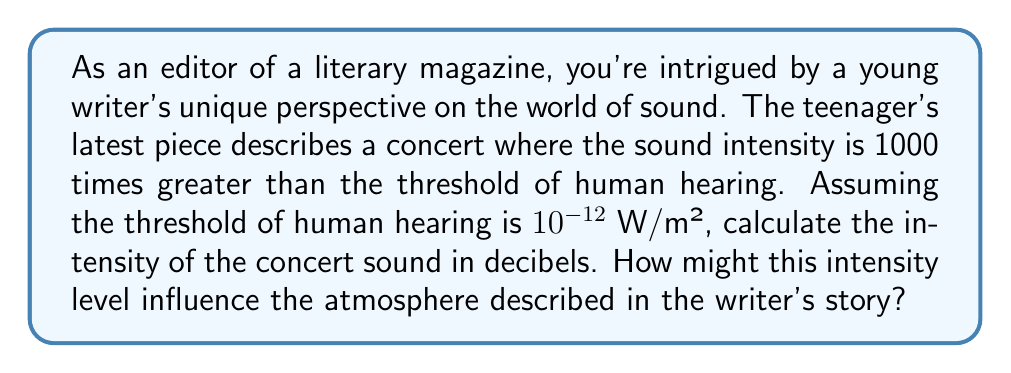Help me with this question. To solve this problem, we'll use the formula for sound intensity level in decibels:

$$ L = 10 \log_{10} \left(\frac{I}{I_0}\right) $$

Where:
$L$ is the sound intensity level in decibels (dB)
$I$ is the intensity of the sound in W/m²
$I_0$ is the reference intensity, which is the threshold of human hearing ($10^{-12}$ W/m²)

Given:
- The concert sound intensity is 1000 times greater than the threshold of human hearing
- $I_0 = 10^{-12}$ W/m²

Step 1: Calculate the intensity of the concert sound ($I$)
$I = 1000 \times I_0 = 1000 \times 10^{-12} = 10^{-9}$ W/m²

Step 2: Plug the values into the formula
$$ L = 10 \log_{10} \left(\frac{10^{-9}}{10^{-12}}\right) $$

Step 3: Simplify the fraction inside the logarithm
$$ L = 10 \log_{10} (1000) $$

Step 4: Calculate the logarithm
$$ L = 10 \times 3 = 30 \text{ dB} $$

The intensity of the concert sound is 30 dB. This relatively low level might suggest a quiet, intimate performance, which could significantly influence the atmosphere described in the writer's story. It might evoke feelings of closeness, introspection, or heightened awareness of subtle sounds.
Answer: 30 dB 